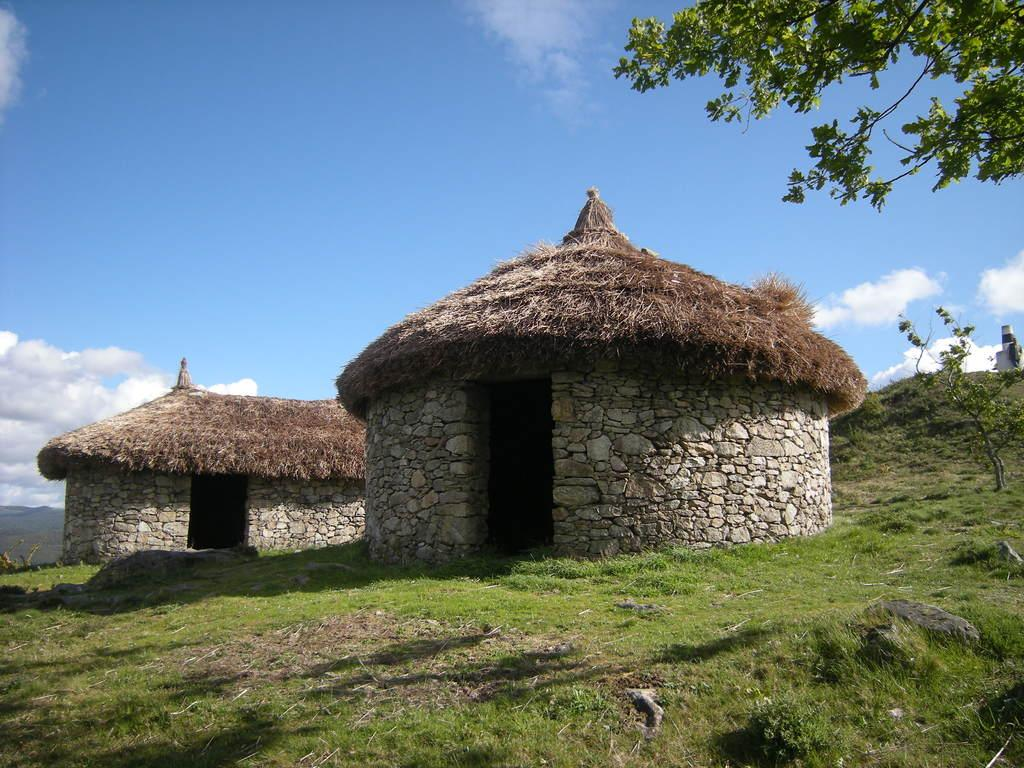What type of structures can be seen in the image? There are huts in the image. What type of vegetation is present in the image? There is grass and plants in the image. What else can be seen in the image besides the huts and vegetation? There are branches and an unspecified object in the image. What is visible in the background of the image? The sky is visible in the background of the image, and there are clouds in the sky. Are there any dinosaurs visible in the image? No, there are no dinosaurs present in the image. What type of pest can be seen in the image? There is no pest visible in the image. 